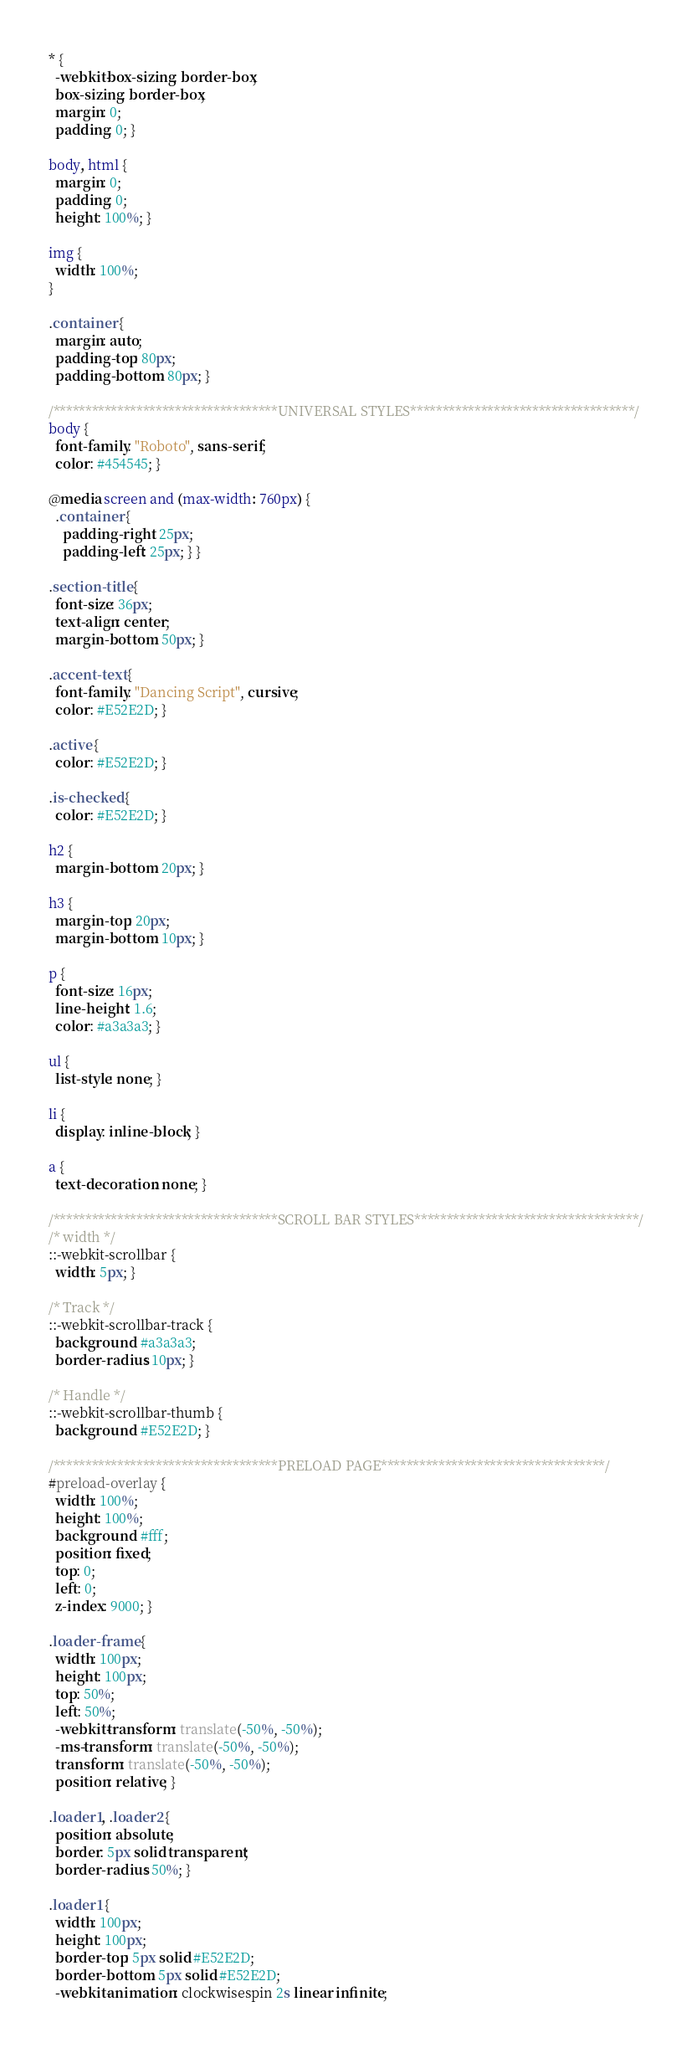<code> <loc_0><loc_0><loc_500><loc_500><_CSS_>* {
  -webkit-box-sizing: border-box;
  box-sizing: border-box;
  margin: 0;
  padding: 0; }

body, html {
  margin: 0;
  padding: 0;
  height: 100%; }

img {
  width: 100%; 
}

.container {
  margin: auto;
  padding-top: 80px;
  padding-bottom: 80px; }

/***********************************UNIVERSAL STYLES***********************************/
body {
  font-family: "Roboto", sans-serif;
  color: #454545; }

@media screen and (max-width: 760px) {
  .container {
    padding-right: 25px;
    padding-left: 25px; } }

.section-title {
  font-size: 36px;
  text-align: center;
  margin-bottom: 50px; }

.accent-text {
  font-family: "Dancing Script", cursive;
  color: #E52E2D; }

.active {
  color: #E52E2D; }

.is-checked {
  color: #E52E2D; }

h2 {
  margin-bottom: 20px; }

h3 {
  margin-top: 20px;
  margin-bottom: 10px; }

p {
  font-size: 16px;
  line-height: 1.6;
  color: #a3a3a3; }

ul {
  list-style: none; }

li {
  display: inline-block; }

a {
  text-decoration: none; }

/***********************************SCROLL BAR STYLES***********************************/
/* width */
::-webkit-scrollbar {
  width: 5px; }

/* Track */
::-webkit-scrollbar-track {
  background: #a3a3a3;
  border-radius: 10px; }

/* Handle */
::-webkit-scrollbar-thumb {
  background: #E52E2D; }

/***********************************PRELOAD PAGE***********************************/
#preload-overlay {
  width: 100%;
  height: 100%;
  background: #fff;
  position: fixed;
  top: 0;
  left: 0;
  z-index: 9000; }

.loader-frame {
  width: 100px;
  height: 100px;
  top: 50%;
  left: 50%;
  -webkit-transform: translate(-50%, -50%);
  -ms-transform: translate(-50%, -50%);
  transform: translate(-50%, -50%);
  position: relative; }

.loader1, .loader2 {
  position: absolute;
  border: 5px solid transparent;
  border-radius: 50%; }

.loader1 {
  width: 100px;
  height: 100px;
  border-top: 5px solid #E52E2D;
  border-bottom: 5px solid #E52E2D;
  -webkit-animation: clockwisespin 2s linear infinite;</code> 